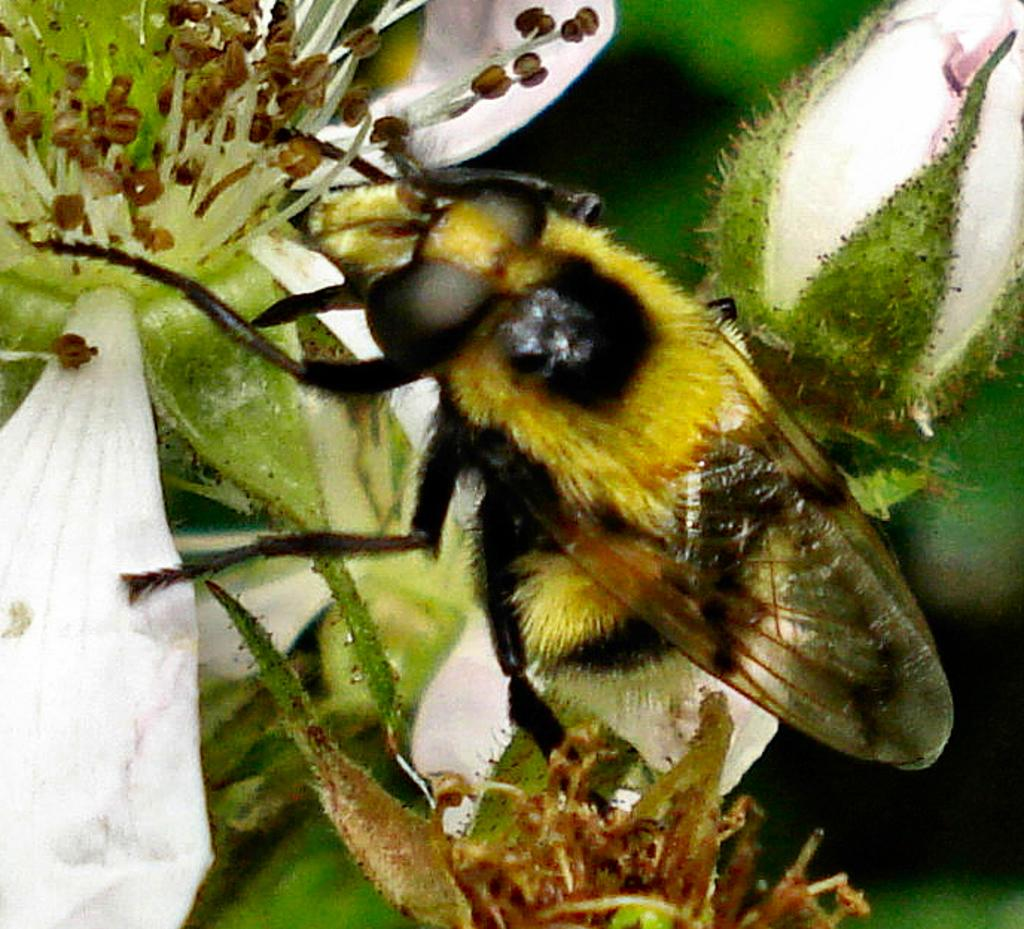What type of living organisms can be seen in the picture? There are flowers and an insect present in the picture. Can you describe the interaction between the insect and the flowers? The insect is present on a flower in the picture. What type of ear can be seen on the insect in the picture? There is no visible ear on the insect in the picture, as insects do not have ears like humans. 